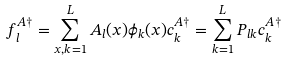<formula> <loc_0><loc_0><loc_500><loc_500>f ^ { A \dagger } _ { l } = \sum _ { x , k = 1 } ^ { L } { A _ { l } ( x ) \phi _ { k } ( x ) c ^ { A \dagger } _ { k } } = \sum _ { k = 1 } ^ { L } { P _ { l k } c ^ { A \dagger } _ { k } }</formula> 